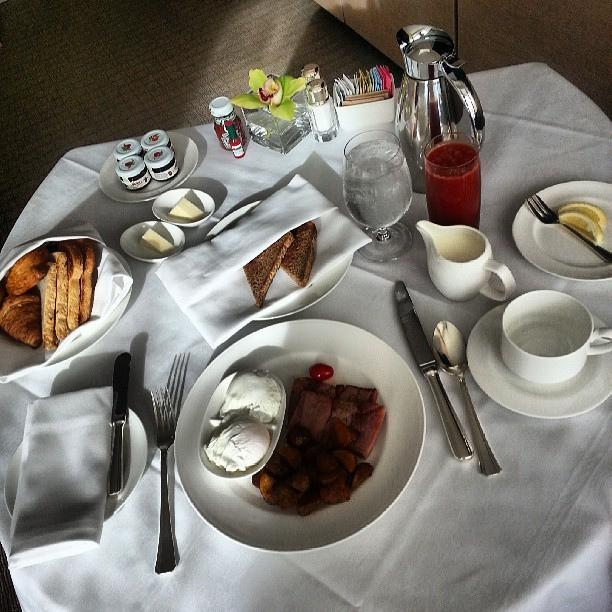When is the type of meal above favorable to be served? breakfast 